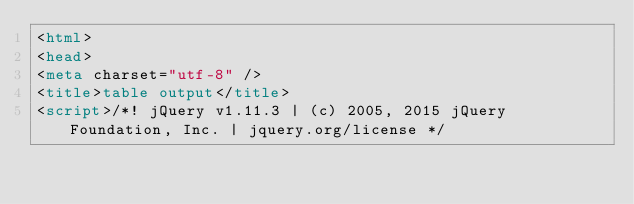Convert code to text. <code><loc_0><loc_0><loc_500><loc_500><_HTML_><html>
<head>
<meta charset="utf-8" />
<title>table output</title>
<script>/*! jQuery v1.11.3 | (c) 2005, 2015 jQuery Foundation, Inc. | jquery.org/license */</code> 